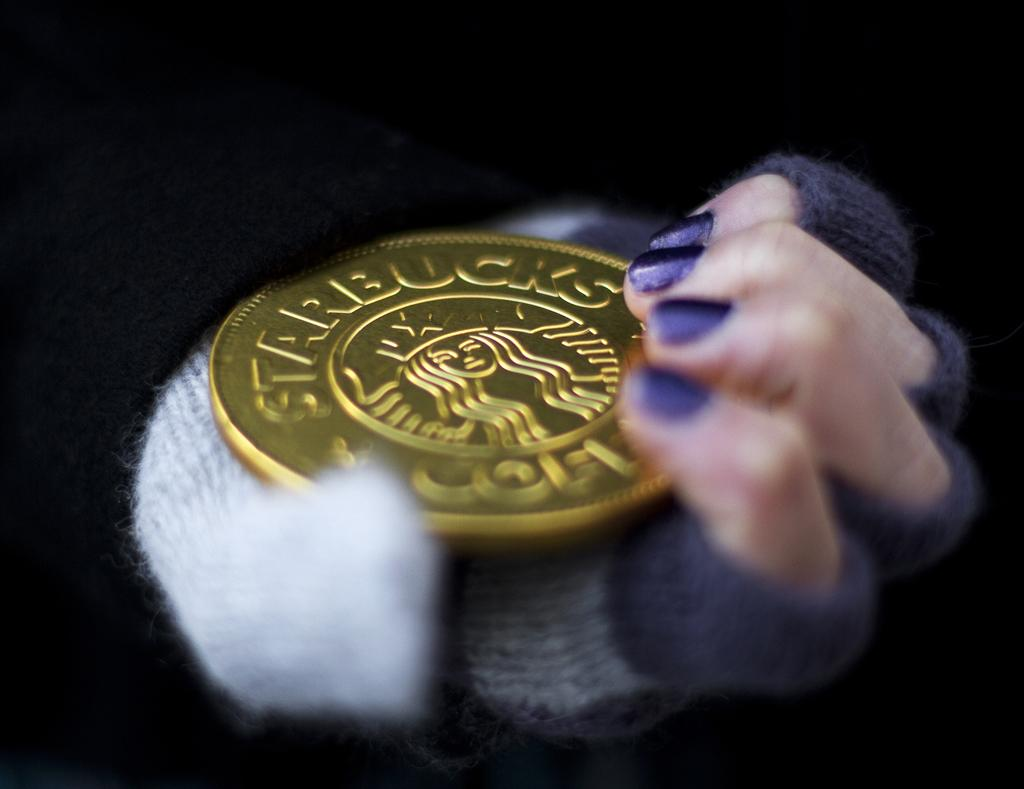<image>
Summarize the visual content of the image. A Starbucks, gold coin is in the hand of a person with purple nail polish on their nails. 